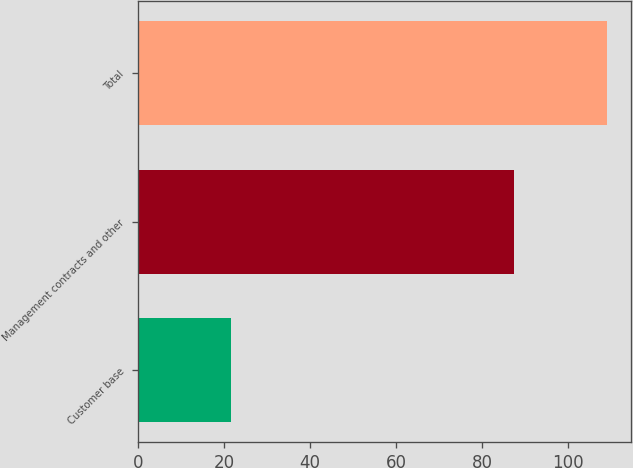Convert chart to OTSL. <chart><loc_0><loc_0><loc_500><loc_500><bar_chart><fcel>Customer base<fcel>Management contracts and other<fcel>Total<nl><fcel>21.7<fcel>87.4<fcel>109.1<nl></chart> 